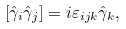Convert formula to latex. <formula><loc_0><loc_0><loc_500><loc_500>\left [ { \hat { \gamma } _ { i } \hat { \gamma } _ { j } } \right ] = i \varepsilon _ { i j k } \hat { \gamma } _ { k } ,</formula> 